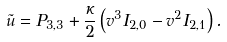Convert formula to latex. <formula><loc_0><loc_0><loc_500><loc_500>\tilde { u } = P _ { 3 , 3 } + \frac { \kappa } { 2 } \left ( v ^ { 3 } I _ { 2 , 0 } - v ^ { 2 } I _ { 2 , 1 } \right ) .</formula> 